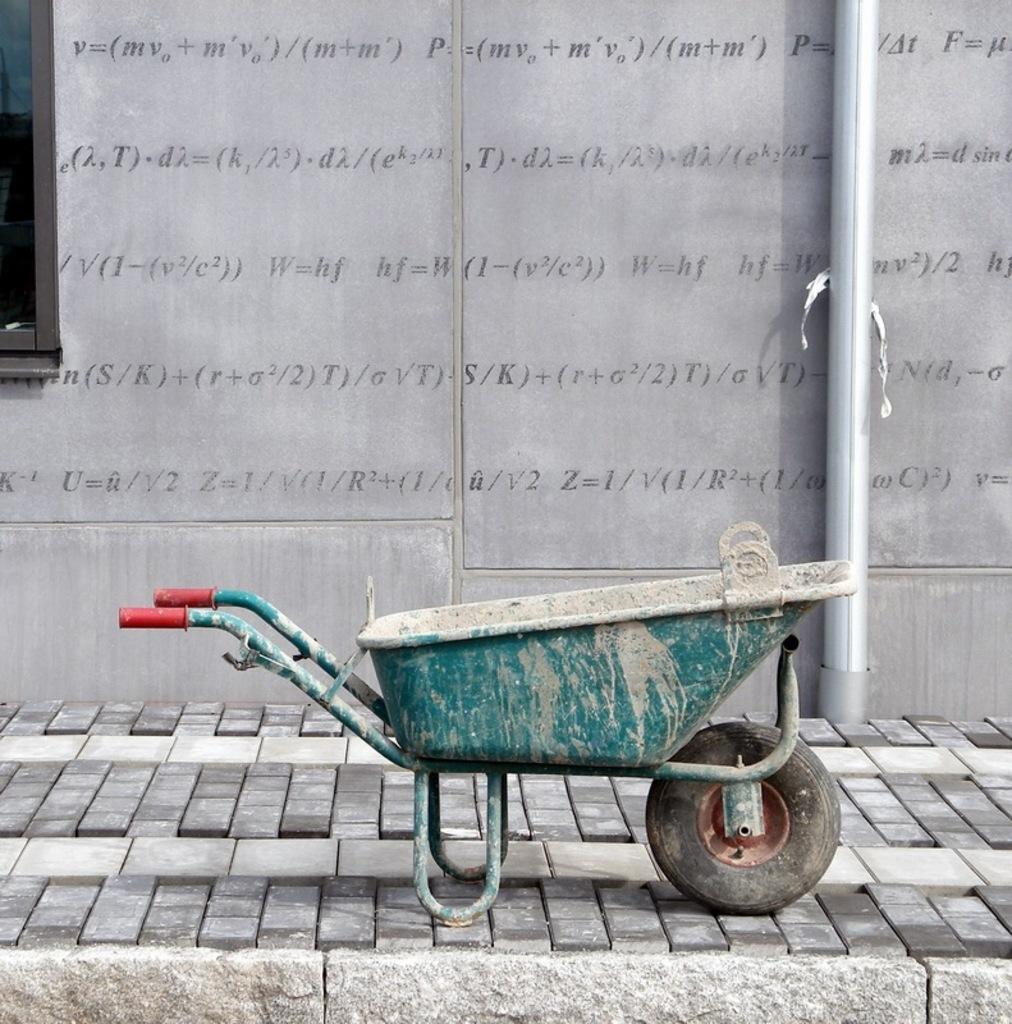How would you summarize this image in a sentence or two? In the foreground we can see footpath and trolley. In the background there are window, pipe and wall. On the wall there is text. 